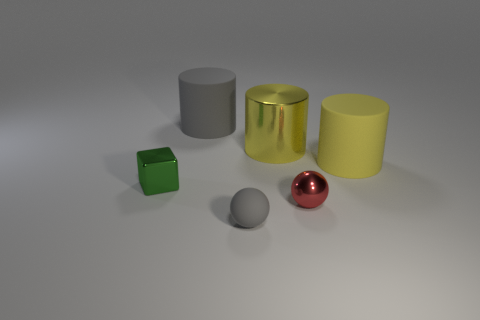What size is the red shiny object that is the same shape as the small rubber thing?
Offer a terse response. Small. Are there any big cylinders on the left side of the tiny gray rubber thing?
Provide a succinct answer. Yes. Is the number of tiny red things that are on the right side of the tiny gray thing the same as the number of big metallic objects?
Offer a very short reply. Yes. There is a tiny green block that is left of the small metallic object that is right of the green cube; is there a tiny ball behind it?
Ensure brevity in your answer.  No. What is the material of the gray cylinder?
Provide a short and direct response. Rubber. How many other things are the same shape as the small green shiny object?
Your answer should be very brief. 0. Is the red metallic object the same shape as the green metallic object?
Ensure brevity in your answer.  No. What number of things are rubber things behind the green object or tiny objects in front of the big yellow rubber cylinder?
Keep it short and to the point. 5. How many things are either tiny gray spheres or metal blocks?
Provide a short and direct response. 2. How many tiny gray balls are on the left side of the metal thing behind the tiny cube?
Make the answer very short. 1. 